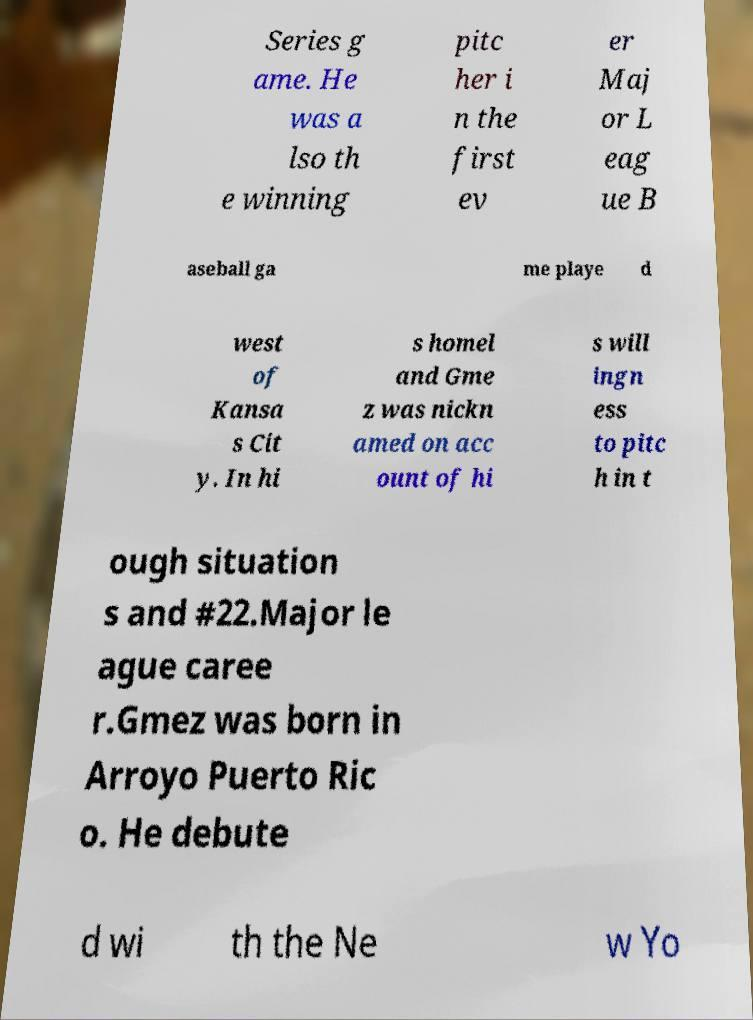Please read and relay the text visible in this image. What does it say? Series g ame. He was a lso th e winning pitc her i n the first ev er Maj or L eag ue B aseball ga me playe d west of Kansa s Cit y. In hi s homel and Gme z was nickn amed on acc ount of hi s will ingn ess to pitc h in t ough situation s and #22.Major le ague caree r.Gmez was born in Arroyo Puerto Ric o. He debute d wi th the Ne w Yo 